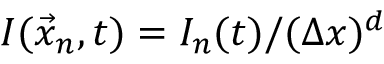<formula> <loc_0><loc_0><loc_500><loc_500>I ( \vec { x } _ { n } , t ) = I _ { n } ( t ) / ( \Delta x ) ^ { d }</formula> 